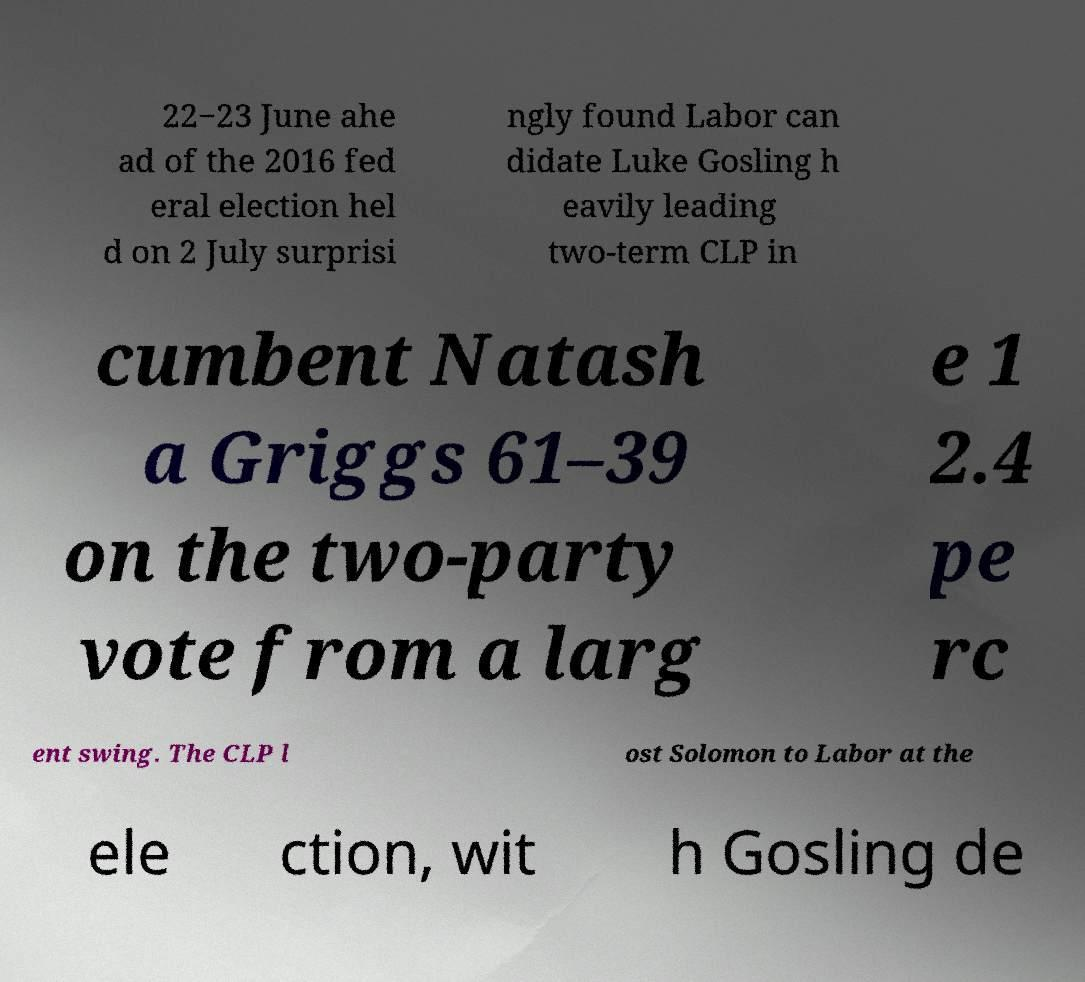Can you accurately transcribe the text from the provided image for me? 22−23 June ahe ad of the 2016 fed eral election hel d on 2 July surprisi ngly found Labor can didate Luke Gosling h eavily leading two-term CLP in cumbent Natash a Griggs 61–39 on the two-party vote from a larg e 1 2.4 pe rc ent swing. The CLP l ost Solomon to Labor at the ele ction, wit h Gosling de 